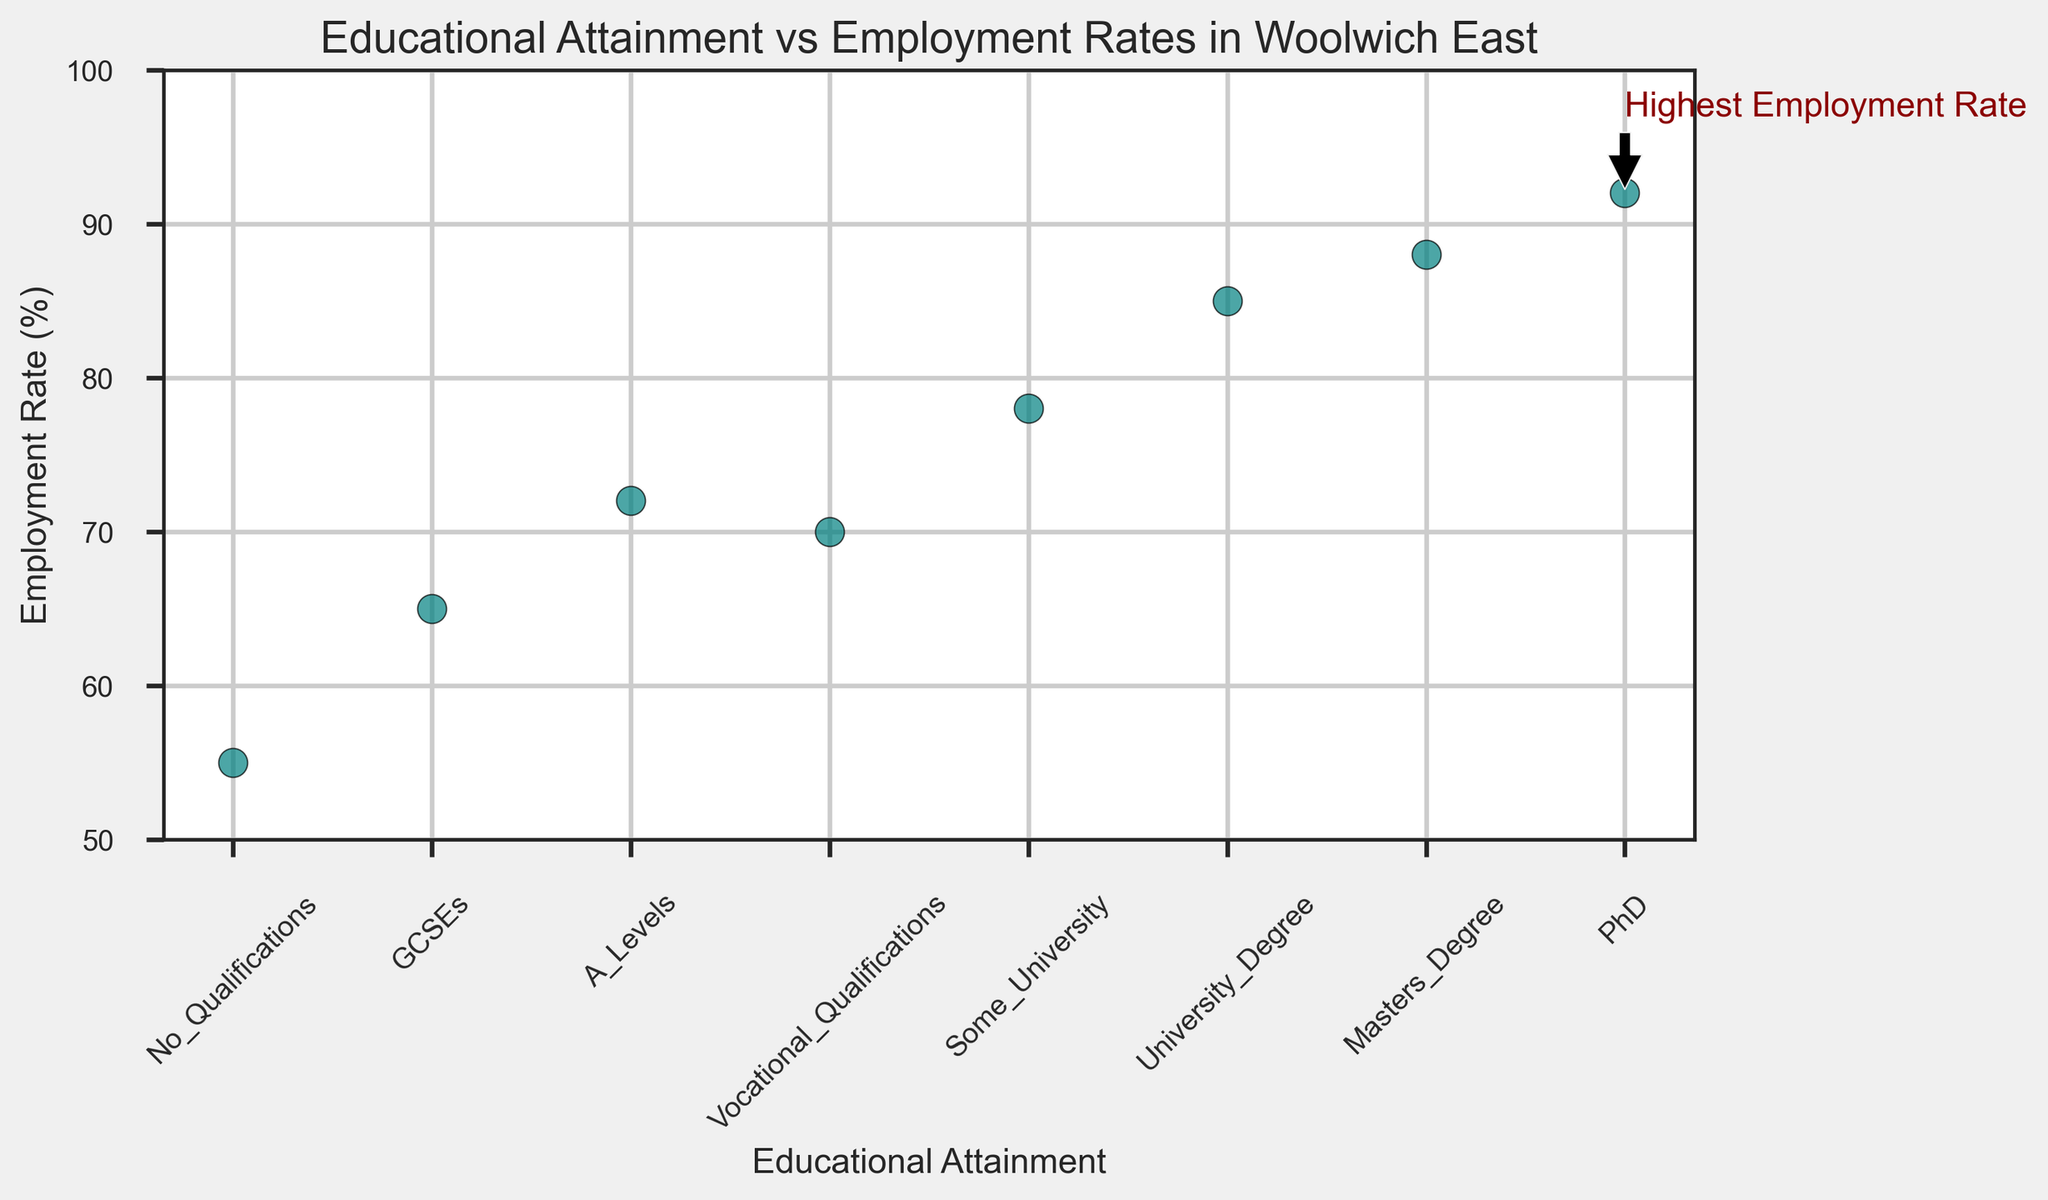What's the educational attainment level with the highest employment rate? The plot annotates the educational attainment level with the highest employment rate, marked by a text label and an arrow pointing to it.
Answer: PhD Which educational attainment level has an employment rate of 70%? By looking at the scatter plot points, Vocational Qualifications corresponds to an employment rate of 70%.
Answer: Vocational Qualifications What is the difference in employment rates between people with GCSEs and those with a University Degree? The employment rate for GCSEs is 65%, and for University Degree is 85%. The difference is calculated as 85% - 65%.
Answer: 20% What is the median employment rate among all the educational attainment levels? To find the median, list the employment rates in ascending order: 55, 65, 70, 72, 78, 85, 88, 92. The middle values are 72 and 78. The median is the average of these two values: (72 + 78) / 2.
Answer: 75% Which educational attainment levels have an employment rate greater than 80%? According to the plot, the employment rates for University Degree (85%), Masters Degree (88%), and PhD (92%) are all greater than 80%.
Answer: University Degree, Masters Degree, PhD How much higher is the employment rate for those with a PhD compared to those with No Qualifications? The employment rate for a PhD is 92%, and for No Qualifications, it is 55%. The difference is 92% - 55%.
Answer: 37% Between A Levels and Some University, which has a higher employment rate and by how much? The employment rate for A Levels is 72%, while for Some University, it is 78%. Some University has a higher rate, and the difference is 78% - 72%.
Answer: Some University, 6% Identify the educational attainment levels that have an employment rate below 75%. By reviewing the plot, the educational attainment levels with employment rates below 75% are No Qualifications (55%), GCSEs (65%), A Levels (72%), and Vocational Qualifications (70%).
Answer: No Qualifications, GCSEs, A Levels, Vocational Qualifications 